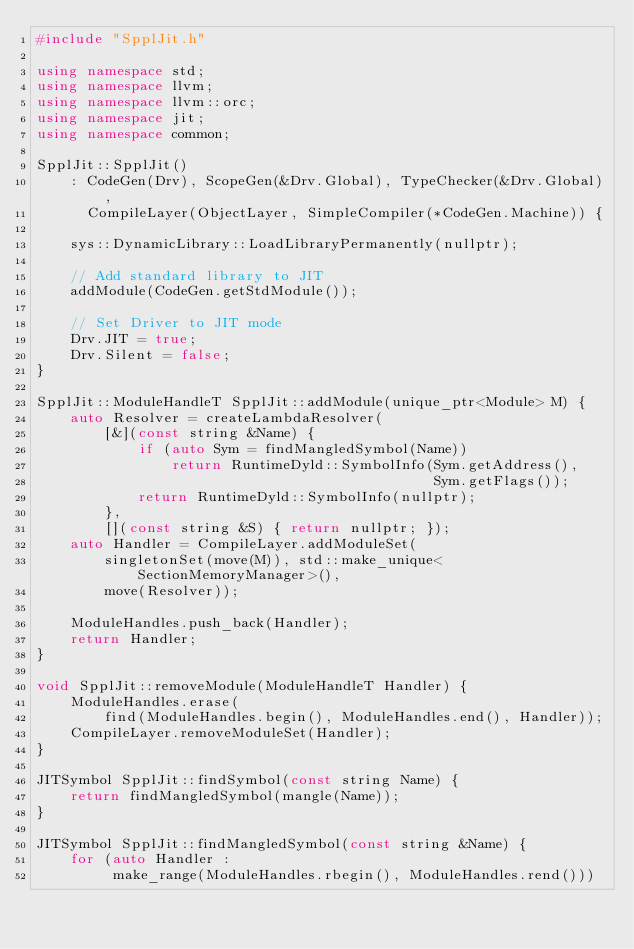Convert code to text. <code><loc_0><loc_0><loc_500><loc_500><_C++_>#include "SpplJit.h"

using namespace std;
using namespace llvm;
using namespace llvm::orc;
using namespace jit;
using namespace common;

SpplJit::SpplJit()
    : CodeGen(Drv), ScopeGen(&Drv.Global), TypeChecker(&Drv.Global),
      CompileLayer(ObjectLayer, SimpleCompiler(*CodeGen.Machine)) {

    sys::DynamicLibrary::LoadLibraryPermanently(nullptr);

    // Add standard library to JIT
    addModule(CodeGen.getStdModule());

    // Set Driver to JIT mode
    Drv.JIT = true;
    Drv.Silent = false;
}

SpplJit::ModuleHandleT SpplJit::addModule(unique_ptr<Module> M) {
    auto Resolver = createLambdaResolver(
        [&](const string &Name) {
            if (auto Sym = findMangledSymbol(Name))
                return RuntimeDyld::SymbolInfo(Sym.getAddress(),
                                               Sym.getFlags());
            return RuntimeDyld::SymbolInfo(nullptr);
        },
        [](const string &S) { return nullptr; });
    auto Handler = CompileLayer.addModuleSet(
        singletonSet(move(M)), std::make_unique<SectionMemoryManager>(),
        move(Resolver));

    ModuleHandles.push_back(Handler);
    return Handler;
}

void SpplJit::removeModule(ModuleHandleT Handler) {
    ModuleHandles.erase(
        find(ModuleHandles.begin(), ModuleHandles.end(), Handler));
    CompileLayer.removeModuleSet(Handler);
}

JITSymbol SpplJit::findSymbol(const string Name) {
    return findMangledSymbol(mangle(Name));
}

JITSymbol SpplJit::findMangledSymbol(const string &Name) {
    for (auto Handler :
         make_range(ModuleHandles.rbegin(), ModuleHandles.rend()))</code> 